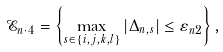Convert formula to latex. <formula><loc_0><loc_0><loc_500><loc_500>\mathcal { E } _ { n \cdot 4 } = \left \{ \max _ { s \in \{ i , j , k , l \} } | \Delta _ { n , s } | \leq \varepsilon _ { n 2 } \right \} ,</formula> 